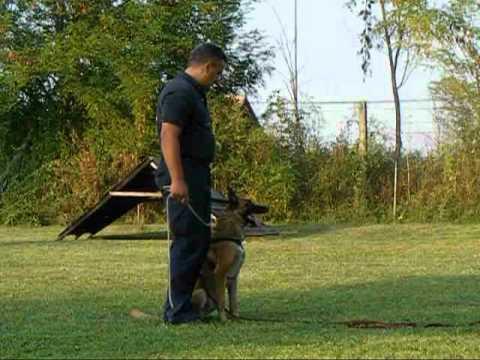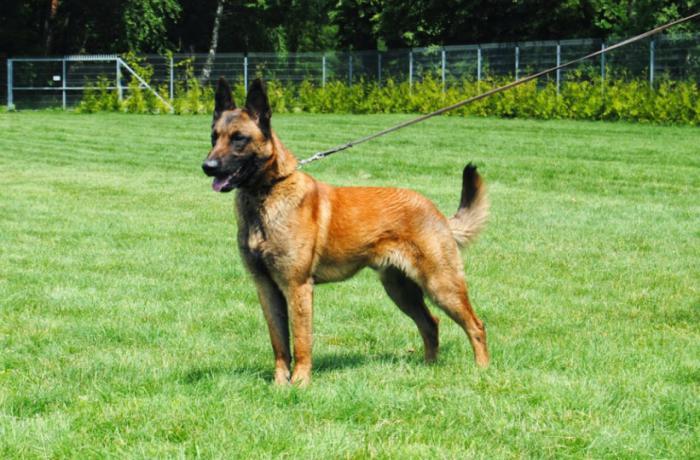The first image is the image on the left, the second image is the image on the right. Given the left and right images, does the statement "There are three dogs in one of the images." hold true? Answer yes or no. No. 